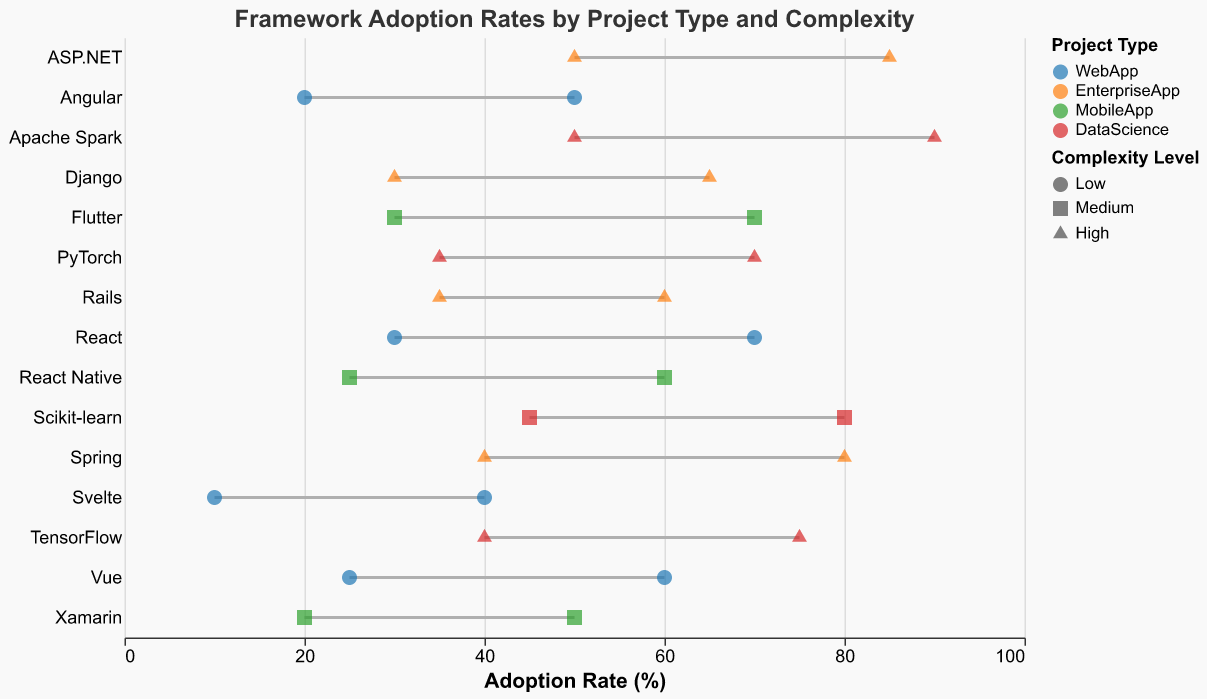What is the maximum adoption rate for the framework "React"? Look for the framework "React" on the y-axis and trace the rule mark to find the maximum adoption rate.
Answer: 70 Which project type has the highest maximum adoption rate? Check all the maximum adoption rates and find the highest value, then match it to its project type.
Answer: DataScience What is the color used to represent "MobileApp" project types? Find the legend that explains the color representation and look for "MobileApp".
Answer: Green Which framework under "EnterpriseApp" has the smallest range in adoption rates? Calculate the range for each framework by subtracting the MinAdoptionRate from the MaxAdoptionRate, and compare them.
Answer: Rails Between "Angular" and "Vue", which has a higher minimum adoption rate? Compare the MinAdoptionRate values for "Angular" and "Vue".
Answer: Vue Which framework associated with "DataScience" projects has the widest adoption rate range? Identify the frameworks under "DataScience" and calculate each range by subtracting MinAdoptionRate from MaxAdoptionRate, then compare the ranges.
Answer: Apache Spark What shape is used to represent 'High' complexity levels? Check the legend that explains the shapes used for "Complexity Level" and look for 'High'.
Answer: Triangle What is the adoption range for "Scikit-learn"? Find the rule representing "Scikit-learn" and note the minimum and maximum adoption rate values.
Answer: 45-80 Which framework for "MobileApp" projects has the highest maximum adoption rate? Look at the maximum adoption rates within the "MobileApp" project type and identify the highest value.
Answer: Flutter 